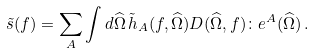<formula> <loc_0><loc_0><loc_500><loc_500>\tilde { s } ( f ) = \sum _ { A } \int d \widehat { \Omega } \, \tilde { h } _ { A } ( f , \widehat { \Omega } ) { D } ( \widehat { \Omega } , f ) \colon { e } ^ { A } ( \widehat { \Omega } ) \, .</formula> 